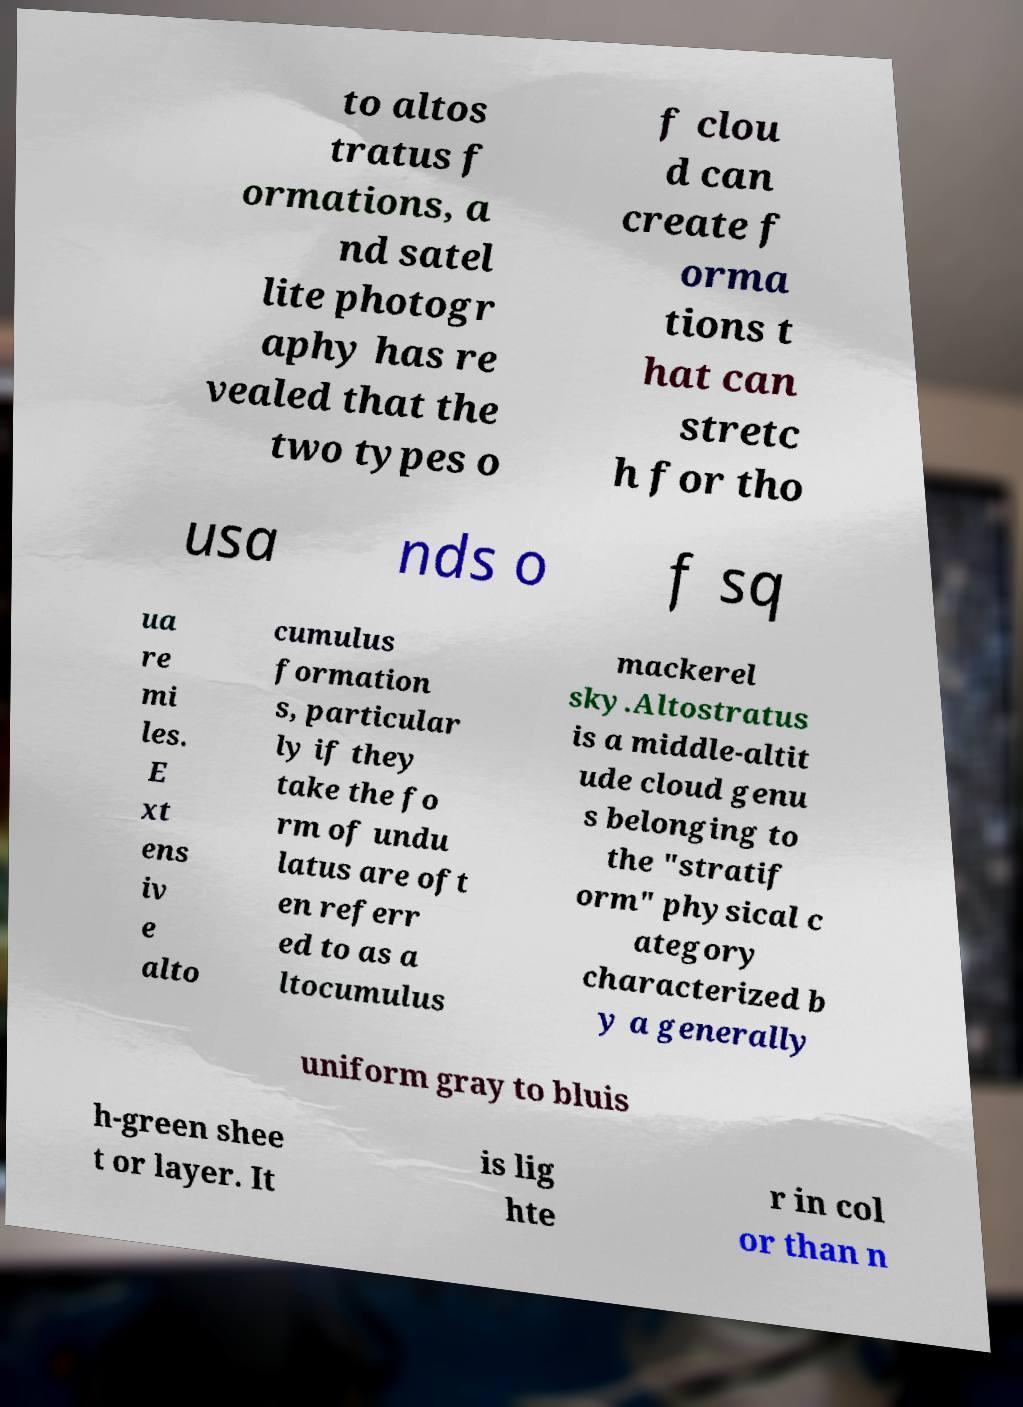Can you read and provide the text displayed in the image?This photo seems to have some interesting text. Can you extract and type it out for me? to altos tratus f ormations, a nd satel lite photogr aphy has re vealed that the two types o f clou d can create f orma tions t hat can stretc h for tho usa nds o f sq ua re mi les. E xt ens iv e alto cumulus formation s, particular ly if they take the fo rm of undu latus are oft en referr ed to as a ltocumulus mackerel sky.Altostratus is a middle-altit ude cloud genu s belonging to the "stratif orm" physical c ategory characterized b y a generally uniform gray to bluis h-green shee t or layer. It is lig hte r in col or than n 